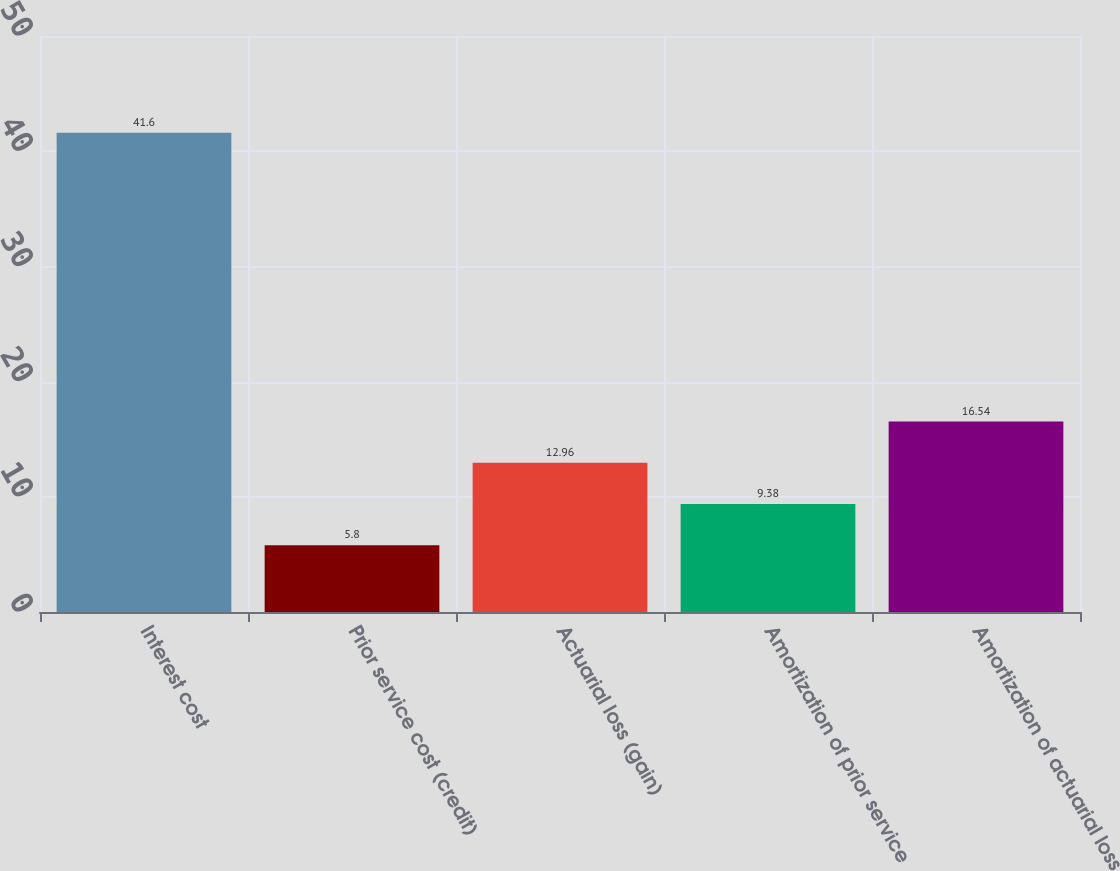<chart> <loc_0><loc_0><loc_500><loc_500><bar_chart><fcel>Interest cost<fcel>Prior service cost (credit)<fcel>Actuarial loss (gain)<fcel>Amortization of prior service<fcel>Amortization of actuarial loss<nl><fcel>41.6<fcel>5.8<fcel>12.96<fcel>9.38<fcel>16.54<nl></chart> 